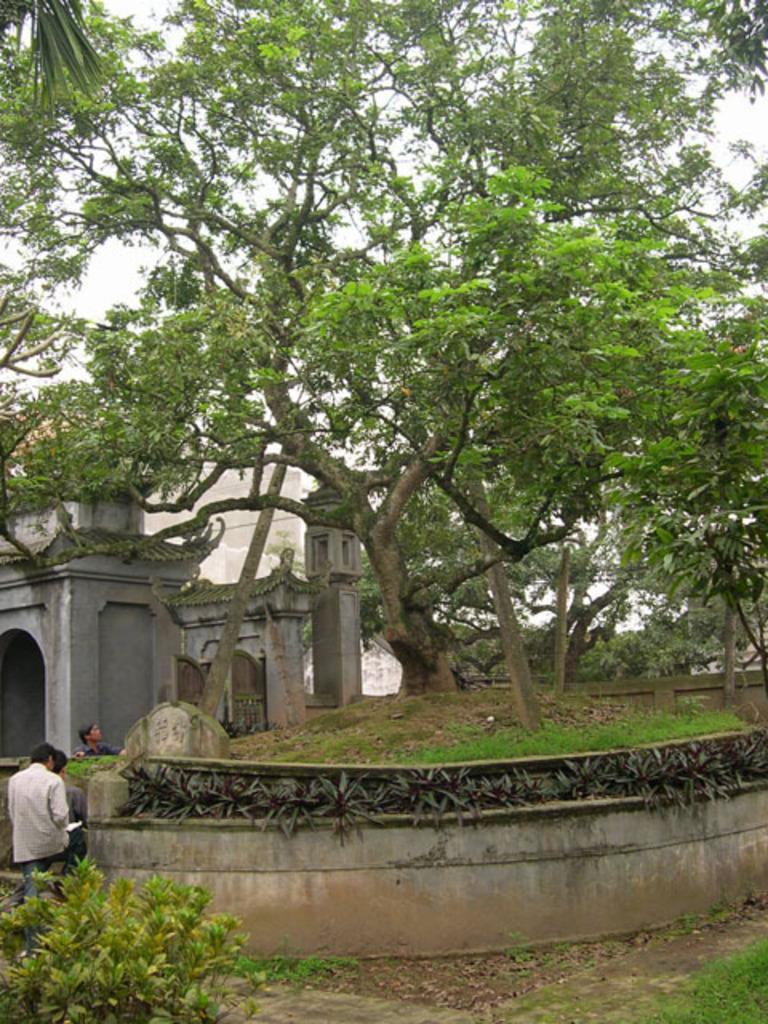In one or two sentences, can you explain what this image depicts? In this image I see the plants, green grass and I see the trees and I see the architecture over here and I see 3 persons over here and I see the sky. 